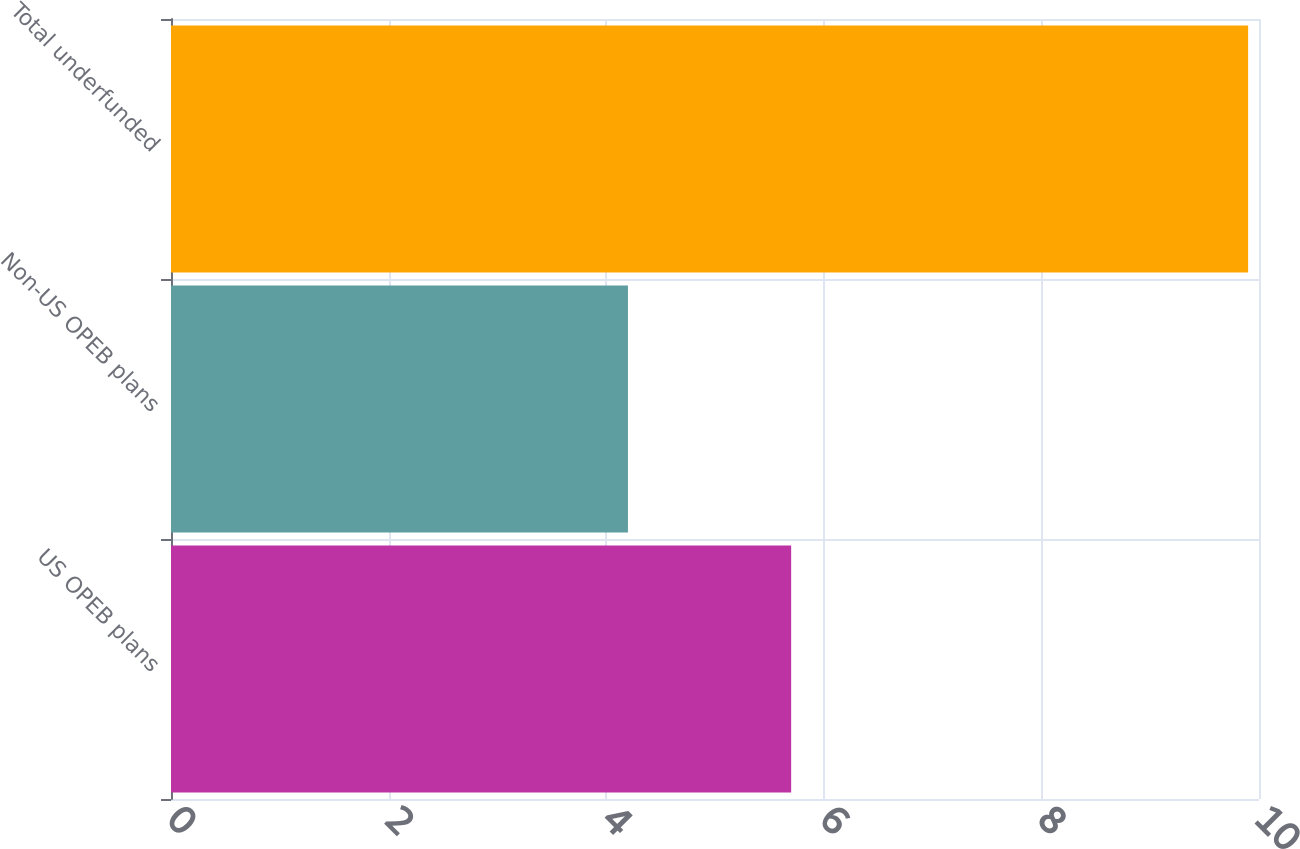<chart> <loc_0><loc_0><loc_500><loc_500><bar_chart><fcel>US OPEB plans<fcel>Non-US OPEB plans<fcel>Total underfunded<nl><fcel>5.7<fcel>4.2<fcel>9.9<nl></chart> 